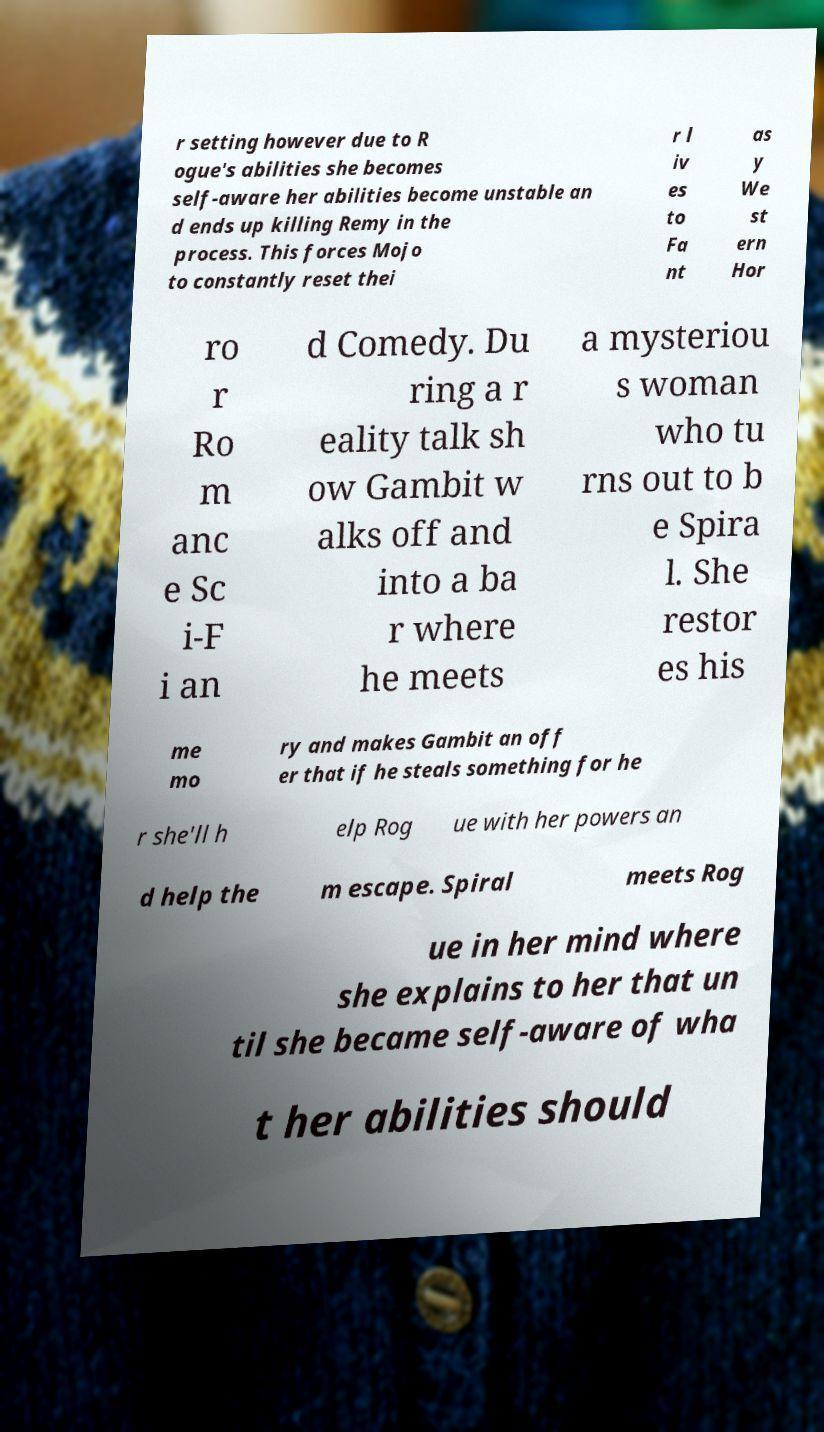Could you assist in decoding the text presented in this image and type it out clearly? r setting however due to R ogue's abilities she becomes self-aware her abilities become unstable an d ends up killing Remy in the process. This forces Mojo to constantly reset thei r l iv es to Fa nt as y We st ern Hor ro r Ro m anc e Sc i-F i an d Comedy. Du ring a r eality talk sh ow Gambit w alks off and into a ba r where he meets a mysteriou s woman who tu rns out to b e Spira l. She restor es his me mo ry and makes Gambit an off er that if he steals something for he r she'll h elp Rog ue with her powers an d help the m escape. Spiral meets Rog ue in her mind where she explains to her that un til she became self-aware of wha t her abilities should 